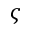Convert formula to latex. <formula><loc_0><loc_0><loc_500><loc_500>\varsigma</formula> 